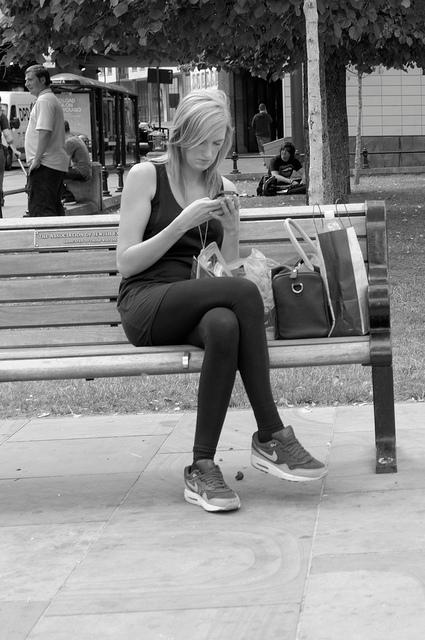What are the shoes that the girl is wearing a good use for? running 